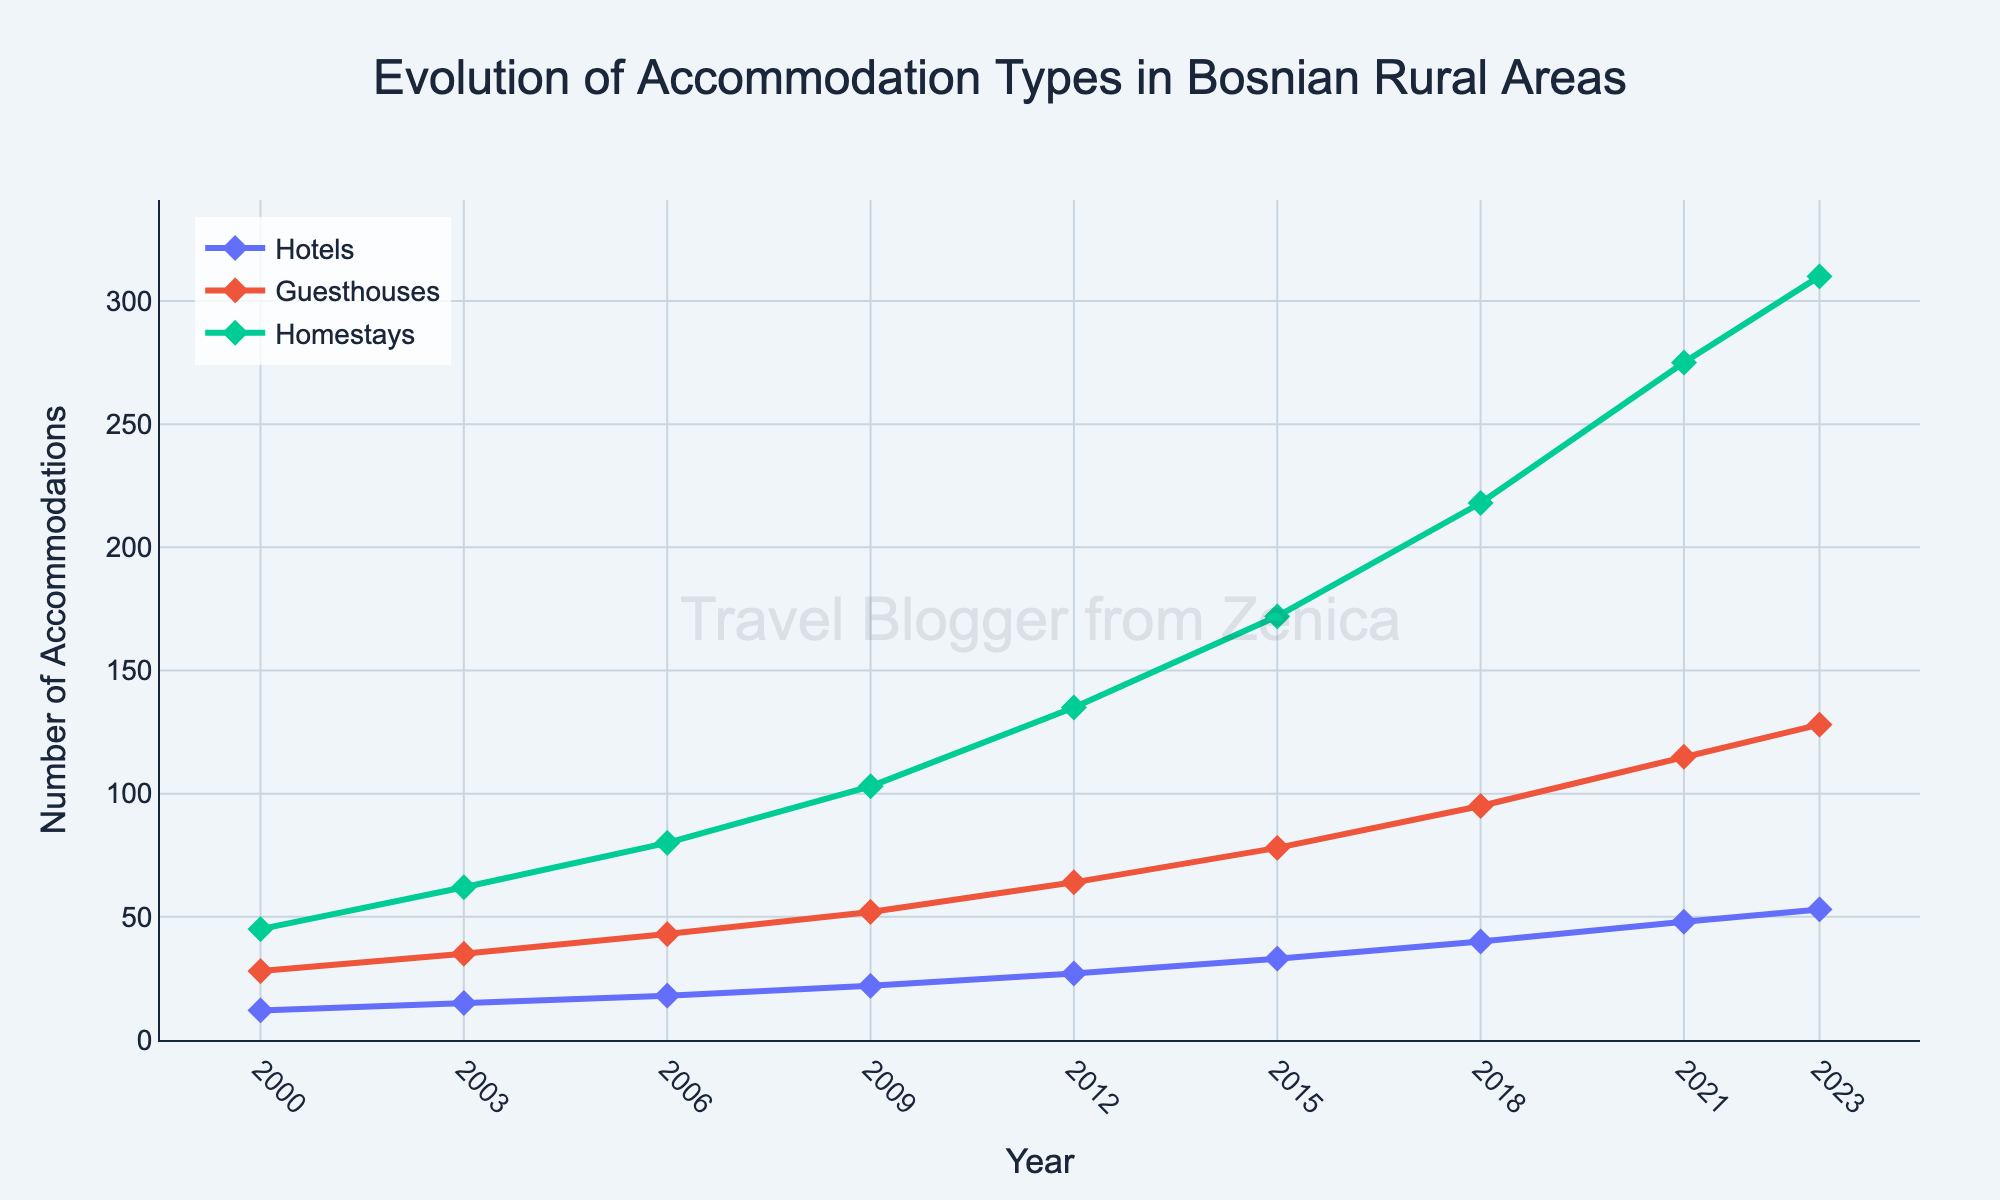What accommodation type showed the highest growth from 2000 to 2023? Look at the lines representing hotels, guesthouses, and homestays. Note the difference between the start and end values: Homestays start at 45 and end at 310, a growth of 265; Guesthouses start at 28 and end at 128, a growth of 100; Hotels start at 12 and end at 53, a growth of 41.
Answer: Homestays By how much did the number of hotels increase between 2006 and 2023? Check the values of the number of hotels in 2006 and 2023: 18 in 2006 and 53 in 2023. Subtract the number of hotels in 2006 from the number in 2023: 53 - 18 = 35.
Answer: 35 Which year saw guesthouses surpass 100 accommodations? Follow the line representing guesthouses and identify when it crosses the 100 accommodations mark. It crosses between 2018 and 2021, specifically by 2021.
Answer: 2021 In which period did homestays show the most significant increase? Examine the slopes between periods for the homestays line. The steepest increase appears between 2018 (218) and 2021 (275), which is an increase of 57.
Answer: 2018-2021 Which accommodation type had the least growth in the 23-year period? Compare the difference in values from 2000 to 2023 for each accommodation type: Hotels (53 - 12 = 41), Guesthouses (128 - 28 = 100), and Homestays (310 - 45 = 265).
Answer: Hotels What is the difference between the number of guesthouses and homestays in 2015? Find the values for guesthouses (78) and homestays (172) in 2015. Subtract guesthouses from homestays: 172 - 78 = 94.
Answer: 94 Between which years did hotels see the slowest growth? Observe the slopes of the line representing hotels between the different periods. The change from 2000 to 2003 is the smallest: 15 - 12 = 3.
Answer: 2000-2003 How many total accommodations were there in 2023? Add the values for hotels, guesthouses, and homestays in 2023: 53 + 128 + 310 = 491.
Answer: 491 Between which years did guesthouses see the greatest increase in number? Identify where the guesthouses line has the steepest slope. Between 2018 (95) and 2021 (115) is an increase of 20.
Answer: 2018-2021 How many more homestays were there than hotels in 2021? Find the values for homestays (275) and hotels (48) in 2021. Subtract hotels from homestays: 275 - 48 = 227.
Answer: 227 